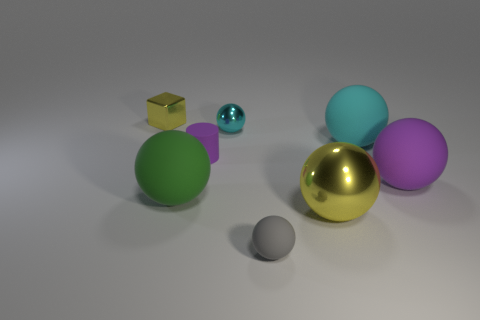Subtract all yellow spheres. How many spheres are left? 5 Subtract all tiny metal balls. How many balls are left? 5 Add 1 red cylinders. How many objects exist? 9 Subtract all yellow spheres. Subtract all blue cubes. How many spheres are left? 5 Subtract all blocks. How many objects are left? 7 Subtract 0 purple blocks. How many objects are left? 8 Subtract all red metal blocks. Subtract all tiny yellow shiny objects. How many objects are left? 7 Add 1 gray spheres. How many gray spheres are left? 2 Add 6 green rubber things. How many green rubber things exist? 7 